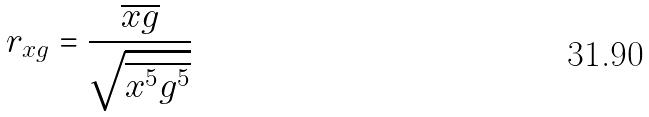<formula> <loc_0><loc_0><loc_500><loc_500>r _ { x g } = \frac { \overline { x g } } { \sqrt { \overline { x ^ { 5 } } \overline { g ^ { 5 } } } }</formula> 